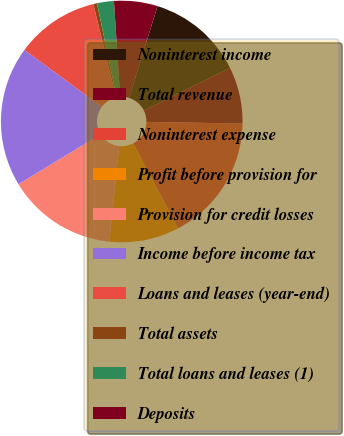<chart> <loc_0><loc_0><loc_500><loc_500><pie_chart><fcel>Noninterest income<fcel>Total revenue<fcel>Noninterest expense<fcel>Profit before provision for<fcel>Provision for credit losses<fcel>Income before income tax<fcel>Loans and leases (year-end)<fcel>Total assets<fcel>Total loans and leases (1)<fcel>Deposits<nl><fcel>12.9%<fcel>7.58%<fcel>17.01%<fcel>9.36%<fcel>14.68%<fcel>18.78%<fcel>11.13%<fcel>0.49%<fcel>2.26%<fcel>5.81%<nl></chart> 